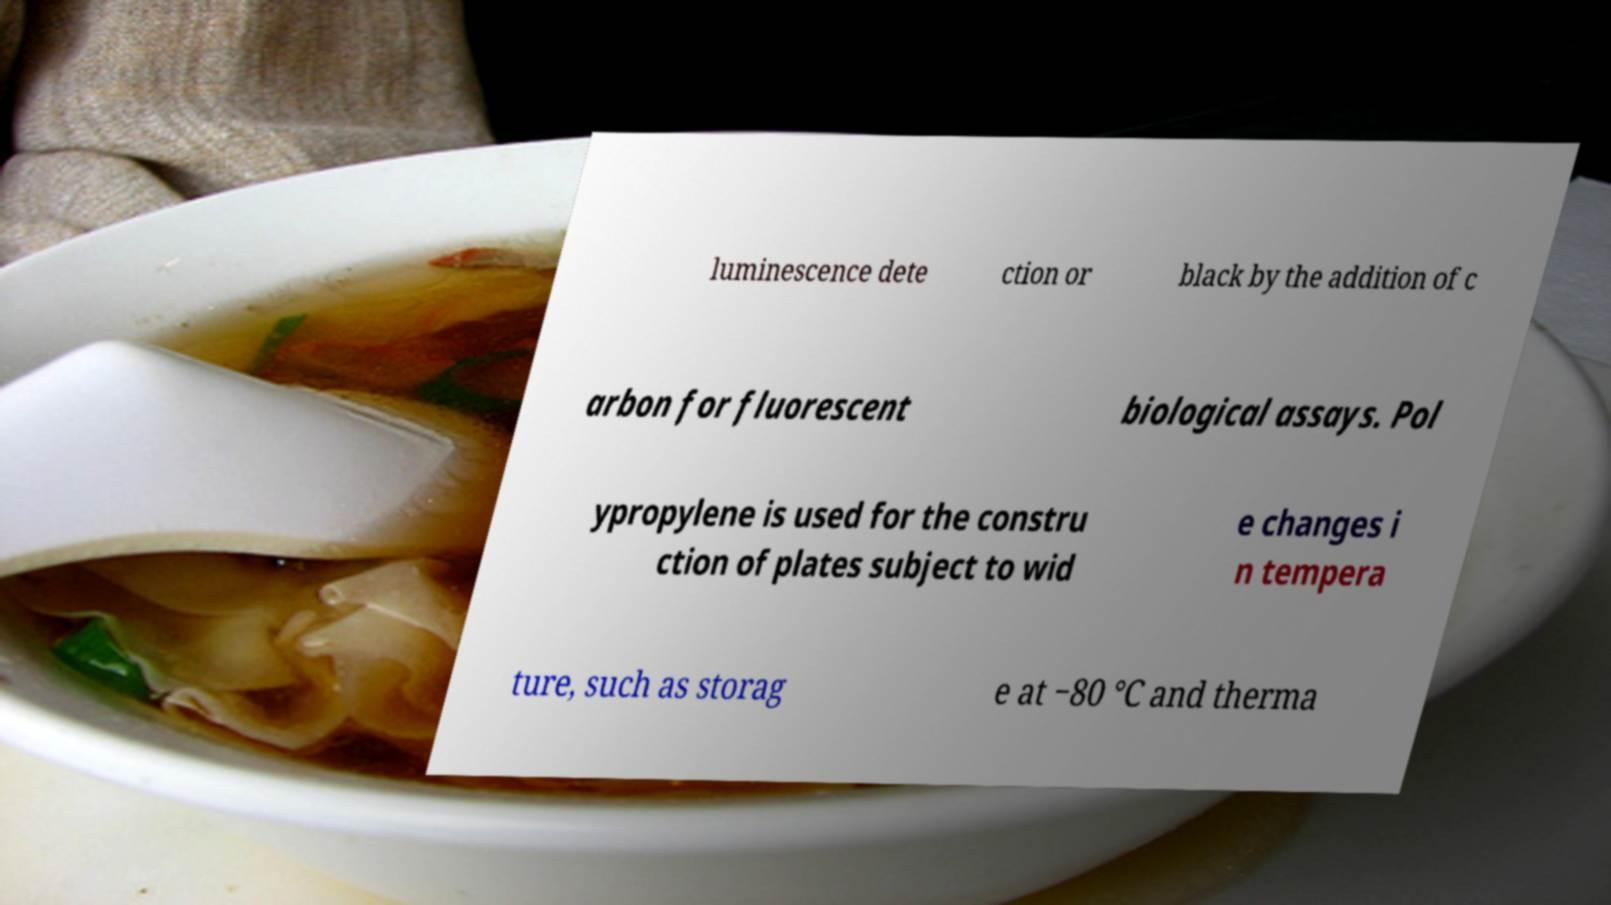Can you read and provide the text displayed in the image?This photo seems to have some interesting text. Can you extract and type it out for me? luminescence dete ction or black by the addition of c arbon for fluorescent biological assays. Pol ypropylene is used for the constru ction of plates subject to wid e changes i n tempera ture, such as storag e at −80 °C and therma 